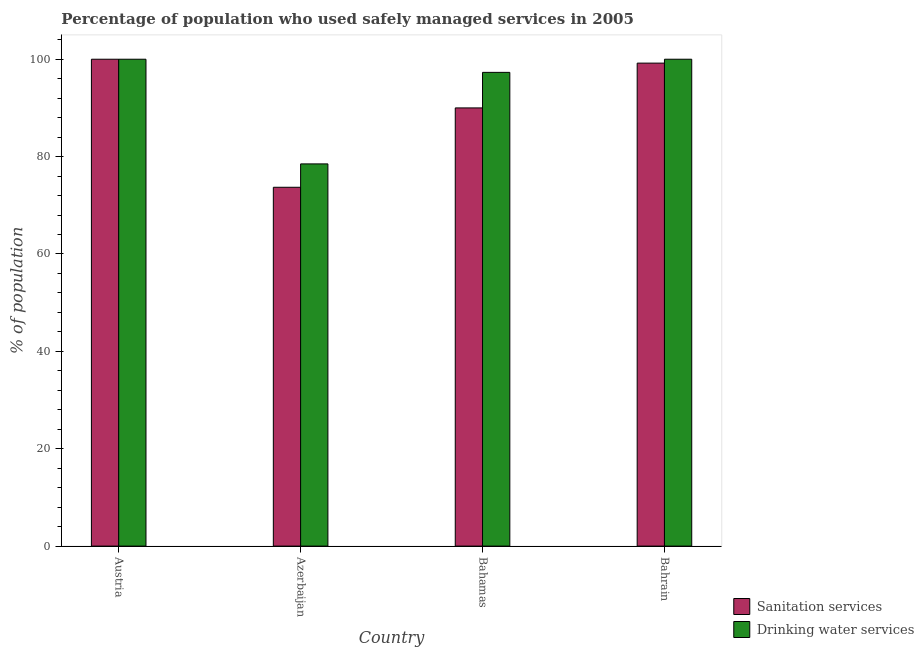How many different coloured bars are there?
Your answer should be compact. 2. How many groups of bars are there?
Offer a terse response. 4. Are the number of bars on each tick of the X-axis equal?
Your answer should be very brief. Yes. How many bars are there on the 2nd tick from the left?
Provide a short and direct response. 2. What is the label of the 2nd group of bars from the left?
Your response must be concise. Azerbaijan. Across all countries, what is the minimum percentage of population who used drinking water services?
Your answer should be very brief. 78.5. In which country was the percentage of population who used sanitation services maximum?
Provide a succinct answer. Austria. In which country was the percentage of population who used drinking water services minimum?
Keep it short and to the point. Azerbaijan. What is the total percentage of population who used sanitation services in the graph?
Ensure brevity in your answer.  362.9. What is the difference between the percentage of population who used sanitation services in Bahrain and the percentage of population who used drinking water services in Austria?
Give a very brief answer. -0.8. What is the average percentage of population who used sanitation services per country?
Provide a short and direct response. 90.72. What is the difference between the percentage of population who used drinking water services and percentage of population who used sanitation services in Azerbaijan?
Your response must be concise. 4.8. What is the ratio of the percentage of population who used sanitation services in Azerbaijan to that in Bahamas?
Give a very brief answer. 0.82. Is the percentage of population who used sanitation services in Austria less than that in Bahamas?
Give a very brief answer. No. Is the difference between the percentage of population who used sanitation services in Azerbaijan and Bahamas greater than the difference between the percentage of population who used drinking water services in Azerbaijan and Bahamas?
Offer a terse response. Yes. What is the difference between the highest and the second highest percentage of population who used sanitation services?
Provide a short and direct response. 0.8. What is the difference between the highest and the lowest percentage of population who used sanitation services?
Make the answer very short. 26.3. In how many countries, is the percentage of population who used sanitation services greater than the average percentage of population who used sanitation services taken over all countries?
Provide a short and direct response. 2. What does the 1st bar from the left in Bahrain represents?
Your response must be concise. Sanitation services. What does the 1st bar from the right in Austria represents?
Your response must be concise. Drinking water services. How many bars are there?
Offer a very short reply. 8. Are all the bars in the graph horizontal?
Provide a succinct answer. No. How many countries are there in the graph?
Give a very brief answer. 4. What is the difference between two consecutive major ticks on the Y-axis?
Your answer should be compact. 20. Does the graph contain grids?
Your answer should be very brief. No. Where does the legend appear in the graph?
Ensure brevity in your answer.  Bottom right. How are the legend labels stacked?
Provide a short and direct response. Vertical. What is the title of the graph?
Provide a succinct answer. Percentage of population who used safely managed services in 2005. Does "Male entrants" appear as one of the legend labels in the graph?
Give a very brief answer. No. What is the label or title of the Y-axis?
Offer a terse response. % of population. What is the % of population in Drinking water services in Austria?
Provide a short and direct response. 100. What is the % of population of Sanitation services in Azerbaijan?
Provide a short and direct response. 73.7. What is the % of population of Drinking water services in Azerbaijan?
Provide a succinct answer. 78.5. What is the % of population in Sanitation services in Bahamas?
Give a very brief answer. 90. What is the % of population in Drinking water services in Bahamas?
Offer a very short reply. 97.3. What is the % of population in Sanitation services in Bahrain?
Offer a terse response. 99.2. Across all countries, what is the maximum % of population of Sanitation services?
Give a very brief answer. 100. Across all countries, what is the maximum % of population of Drinking water services?
Provide a short and direct response. 100. Across all countries, what is the minimum % of population of Sanitation services?
Your answer should be very brief. 73.7. Across all countries, what is the minimum % of population of Drinking water services?
Give a very brief answer. 78.5. What is the total % of population in Sanitation services in the graph?
Provide a short and direct response. 362.9. What is the total % of population in Drinking water services in the graph?
Provide a short and direct response. 375.8. What is the difference between the % of population of Sanitation services in Austria and that in Azerbaijan?
Keep it short and to the point. 26.3. What is the difference between the % of population in Drinking water services in Austria and that in Azerbaijan?
Offer a very short reply. 21.5. What is the difference between the % of population of Sanitation services in Austria and that in Bahrain?
Give a very brief answer. 0.8. What is the difference between the % of population of Drinking water services in Austria and that in Bahrain?
Ensure brevity in your answer.  0. What is the difference between the % of population of Sanitation services in Azerbaijan and that in Bahamas?
Your answer should be compact. -16.3. What is the difference between the % of population in Drinking water services in Azerbaijan and that in Bahamas?
Provide a short and direct response. -18.8. What is the difference between the % of population of Sanitation services in Azerbaijan and that in Bahrain?
Give a very brief answer. -25.5. What is the difference between the % of population of Drinking water services in Azerbaijan and that in Bahrain?
Provide a succinct answer. -21.5. What is the difference between the % of population of Sanitation services in Bahamas and that in Bahrain?
Ensure brevity in your answer.  -9.2. What is the difference between the % of population in Sanitation services in Austria and the % of population in Drinking water services in Bahamas?
Offer a very short reply. 2.7. What is the difference between the % of population in Sanitation services in Austria and the % of population in Drinking water services in Bahrain?
Provide a succinct answer. 0. What is the difference between the % of population in Sanitation services in Azerbaijan and the % of population in Drinking water services in Bahamas?
Offer a terse response. -23.6. What is the difference between the % of population in Sanitation services in Azerbaijan and the % of population in Drinking water services in Bahrain?
Provide a short and direct response. -26.3. What is the difference between the % of population of Sanitation services in Bahamas and the % of population of Drinking water services in Bahrain?
Keep it short and to the point. -10. What is the average % of population in Sanitation services per country?
Keep it short and to the point. 90.72. What is the average % of population of Drinking water services per country?
Provide a succinct answer. 93.95. What is the difference between the % of population in Sanitation services and % of population in Drinking water services in Austria?
Provide a short and direct response. 0. What is the difference between the % of population of Sanitation services and % of population of Drinking water services in Bahamas?
Provide a short and direct response. -7.3. What is the difference between the % of population in Sanitation services and % of population in Drinking water services in Bahrain?
Ensure brevity in your answer.  -0.8. What is the ratio of the % of population of Sanitation services in Austria to that in Azerbaijan?
Provide a short and direct response. 1.36. What is the ratio of the % of population in Drinking water services in Austria to that in Azerbaijan?
Offer a very short reply. 1.27. What is the ratio of the % of population in Sanitation services in Austria to that in Bahamas?
Ensure brevity in your answer.  1.11. What is the ratio of the % of population of Drinking water services in Austria to that in Bahamas?
Provide a short and direct response. 1.03. What is the ratio of the % of population in Drinking water services in Austria to that in Bahrain?
Provide a short and direct response. 1. What is the ratio of the % of population of Sanitation services in Azerbaijan to that in Bahamas?
Your response must be concise. 0.82. What is the ratio of the % of population of Drinking water services in Azerbaijan to that in Bahamas?
Your answer should be compact. 0.81. What is the ratio of the % of population in Sanitation services in Azerbaijan to that in Bahrain?
Your response must be concise. 0.74. What is the ratio of the % of population of Drinking water services in Azerbaijan to that in Bahrain?
Provide a succinct answer. 0.79. What is the ratio of the % of population of Sanitation services in Bahamas to that in Bahrain?
Your answer should be very brief. 0.91. What is the ratio of the % of population of Drinking water services in Bahamas to that in Bahrain?
Keep it short and to the point. 0.97. What is the difference between the highest and the second highest % of population in Sanitation services?
Your answer should be very brief. 0.8. What is the difference between the highest and the second highest % of population of Drinking water services?
Ensure brevity in your answer.  0. What is the difference between the highest and the lowest % of population in Sanitation services?
Provide a short and direct response. 26.3. 